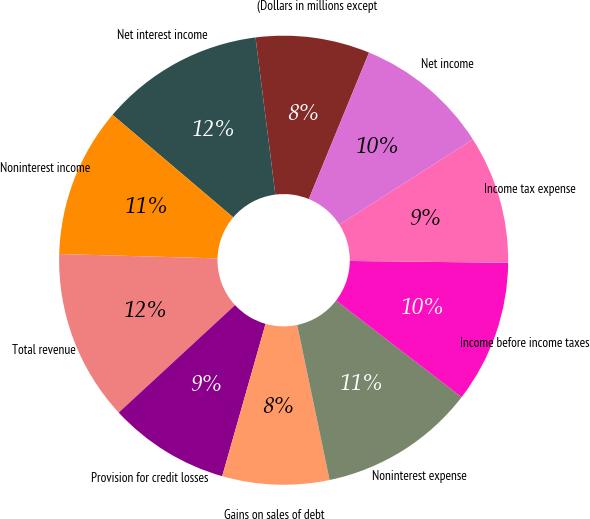<chart> <loc_0><loc_0><loc_500><loc_500><pie_chart><fcel>(Dollars in millions except<fcel>Net interest income<fcel>Noninterest income<fcel>Total revenue<fcel>Provision for credit losses<fcel>Gains on sales of debt<fcel>Noninterest expense<fcel>Income before income taxes<fcel>Income tax expense<fcel>Net income<nl><fcel>8.21%<fcel>11.79%<fcel>10.77%<fcel>12.31%<fcel>8.72%<fcel>7.69%<fcel>11.28%<fcel>10.26%<fcel>9.23%<fcel>9.74%<nl></chart> 